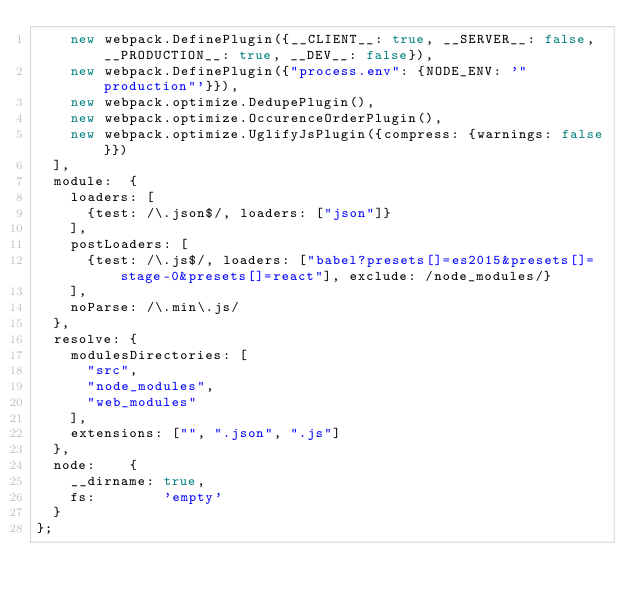<code> <loc_0><loc_0><loc_500><loc_500><_JavaScript_>		new webpack.DefinePlugin({__CLIENT__: true, __SERVER__: false, __PRODUCTION__: true, __DEV__: false}),
		new webpack.DefinePlugin({"process.env": {NODE_ENV: '"production"'}}),
		new webpack.optimize.DedupePlugin(),
		new webpack.optimize.OccurenceOrderPlugin(),
		new webpack.optimize.UglifyJsPlugin({compress: {warnings: false}})
	],
	module:  {
		loaders: [
			{test: /\.json$/, loaders: ["json"]}
		],
		postLoaders: [
			{test: /\.js$/, loaders: ["babel?presets[]=es2015&presets[]=stage-0&presets[]=react"], exclude: /node_modules/}
		],
		noParse: /\.min\.js/
	},
	resolve: {
		modulesDirectories: [
			"src",
			"node_modules",
			"web_modules"
		],
		extensions: ["", ".json", ".js"]
	},
	node:    {
		__dirname: true,
		fs:        'empty'
	}
};
</code> 